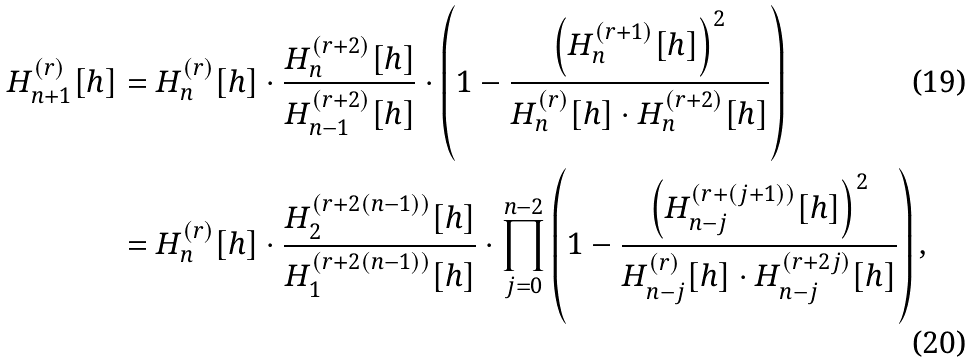Convert formula to latex. <formula><loc_0><loc_0><loc_500><loc_500>H _ { n + 1 } ^ { ( r ) } [ h ] & = H _ { n } ^ { ( r ) } [ h ] \cdot \frac { H _ { n } ^ { ( r + 2 ) } [ h ] } { H _ { n - 1 } ^ { ( r + 2 ) } [ h ] } \cdot \left ( 1 - \frac { \left ( H _ { n } ^ { ( r + 1 ) } [ h ] \right ) ^ { 2 } } { H _ { n } ^ { ( r ) } [ h ] \cdot H _ { n } ^ { ( r + 2 ) } [ h ] } \right ) \\ & = H _ { n } ^ { ( r ) } [ h ] \cdot \frac { H _ { 2 } ^ { ( r + 2 ( n - 1 ) ) } [ h ] } { H _ { 1 } ^ { ( r + 2 ( n - 1 ) ) } [ h ] } \cdot \prod _ { j = 0 } ^ { n - 2 } \left ( 1 - \frac { \left ( H _ { n - j } ^ { ( r + ( j + 1 ) ) } [ h ] \right ) ^ { 2 } } { H _ { n - j } ^ { ( r ) } [ h ] \cdot H _ { n - j } ^ { ( r + 2 j ) } [ h ] } \right ) ,</formula> 